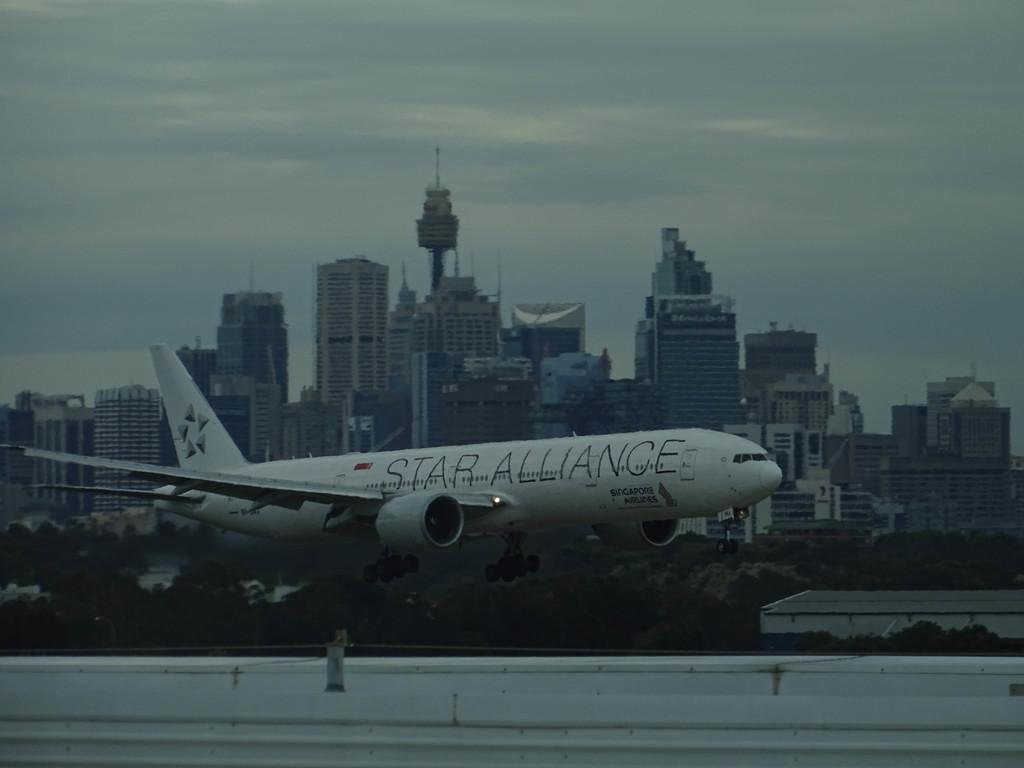<image>
Summarize the visual content of the image. A white airplane with the words Star Alliance written on the side 